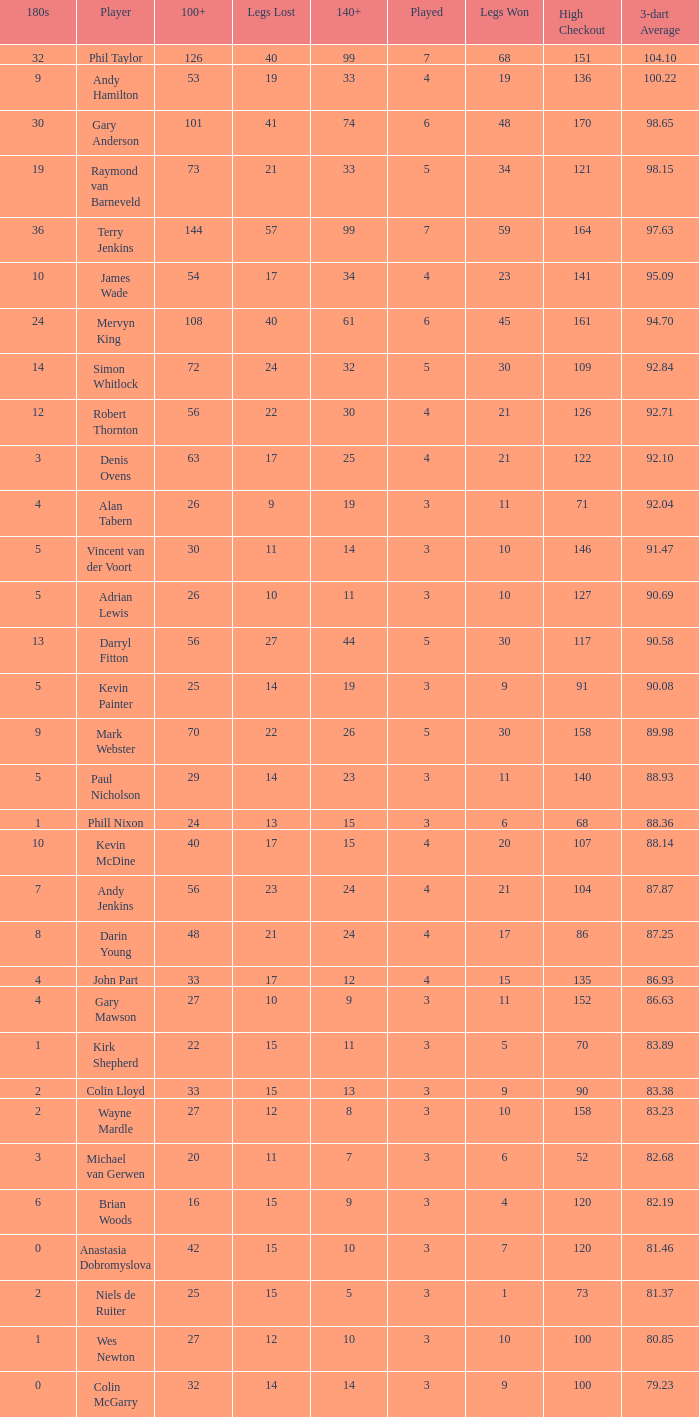Write the full table. {'header': ['180s', 'Player', '100+', 'Legs Lost', '140+', 'Played', 'Legs Won', 'High Checkout', '3-dart Average'], 'rows': [['32', 'Phil Taylor', '126', '40', '99', '7', '68', '151', '104.10'], ['9', 'Andy Hamilton', '53', '19', '33', '4', '19', '136', '100.22'], ['30', 'Gary Anderson', '101', '41', '74', '6', '48', '170', '98.65'], ['19', 'Raymond van Barneveld', '73', '21', '33', '5', '34', '121', '98.15'], ['36', 'Terry Jenkins', '144', '57', '99', '7', '59', '164', '97.63'], ['10', 'James Wade', '54', '17', '34', '4', '23', '141', '95.09'], ['24', 'Mervyn King', '108', '40', '61', '6', '45', '161', '94.70'], ['14', 'Simon Whitlock', '72', '24', '32', '5', '30', '109', '92.84'], ['12', 'Robert Thornton', '56', '22', '30', '4', '21', '126', '92.71'], ['3', 'Denis Ovens', '63', '17', '25', '4', '21', '122', '92.10'], ['4', 'Alan Tabern', '26', '9', '19', '3', '11', '71', '92.04'], ['5', 'Vincent van der Voort', '30', '11', '14', '3', '10', '146', '91.47'], ['5', 'Adrian Lewis', '26', '10', '11', '3', '10', '127', '90.69'], ['13', 'Darryl Fitton', '56', '27', '44', '5', '30', '117', '90.58'], ['5', 'Kevin Painter', '25', '14', '19', '3', '9', '91', '90.08'], ['9', 'Mark Webster', '70', '22', '26', '5', '30', '158', '89.98'], ['5', 'Paul Nicholson', '29', '14', '23', '3', '11', '140', '88.93'], ['1', 'Phill Nixon', '24', '13', '15', '3', '6', '68', '88.36'], ['10', 'Kevin McDine', '40', '17', '15', '4', '20', '107', '88.14'], ['7', 'Andy Jenkins', '56', '23', '24', '4', '21', '104', '87.87'], ['8', 'Darin Young', '48', '21', '24', '4', '17', '86', '87.25'], ['4', 'John Part', '33', '17', '12', '4', '15', '135', '86.93'], ['4', 'Gary Mawson', '27', '10', '9', '3', '11', '152', '86.63'], ['1', 'Kirk Shepherd', '22', '15', '11', '3', '5', '70', '83.89'], ['2', 'Colin Lloyd', '33', '15', '13', '3', '9', '90', '83.38'], ['2', 'Wayne Mardle', '27', '12', '8', '3', '10', '158', '83.23'], ['3', 'Michael van Gerwen', '20', '11', '7', '3', '6', '52', '82.68'], ['6', 'Brian Woods', '16', '15', '9', '3', '4', '120', '82.19'], ['0', 'Anastasia Dobromyslova', '42', '15', '10', '3', '7', '120', '81.46'], ['2', 'Niels de Ruiter', '25', '15', '5', '3', '1', '73', '81.37'], ['1', 'Wes Newton', '27', '12', '10', '3', '10', '100', '80.85'], ['0', 'Colin McGarry', '32', '14', '14', '3', '9', '100', '79.23']]} What is the number of high checkout when legs Lost is 17, 140+ is 15, and played is larger than 4? None. 